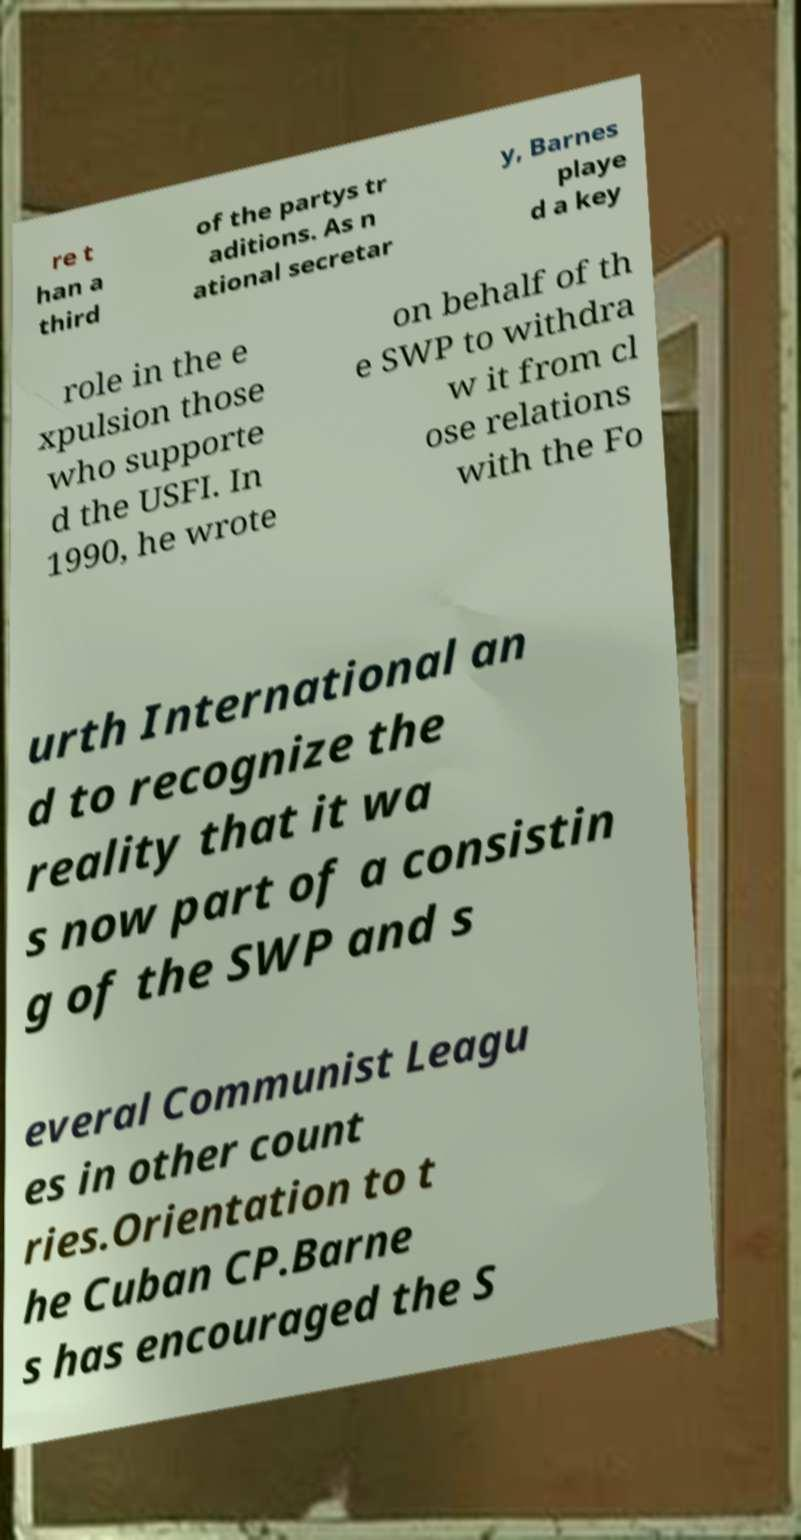Please identify and transcribe the text found in this image. re t han a third of the partys tr aditions. As n ational secretar y, Barnes playe d a key role in the e xpulsion those who supporte d the USFI. In 1990, he wrote on behalf of th e SWP to withdra w it from cl ose relations with the Fo urth International an d to recognize the reality that it wa s now part of a consistin g of the SWP and s everal Communist Leagu es in other count ries.Orientation to t he Cuban CP.Barne s has encouraged the S 